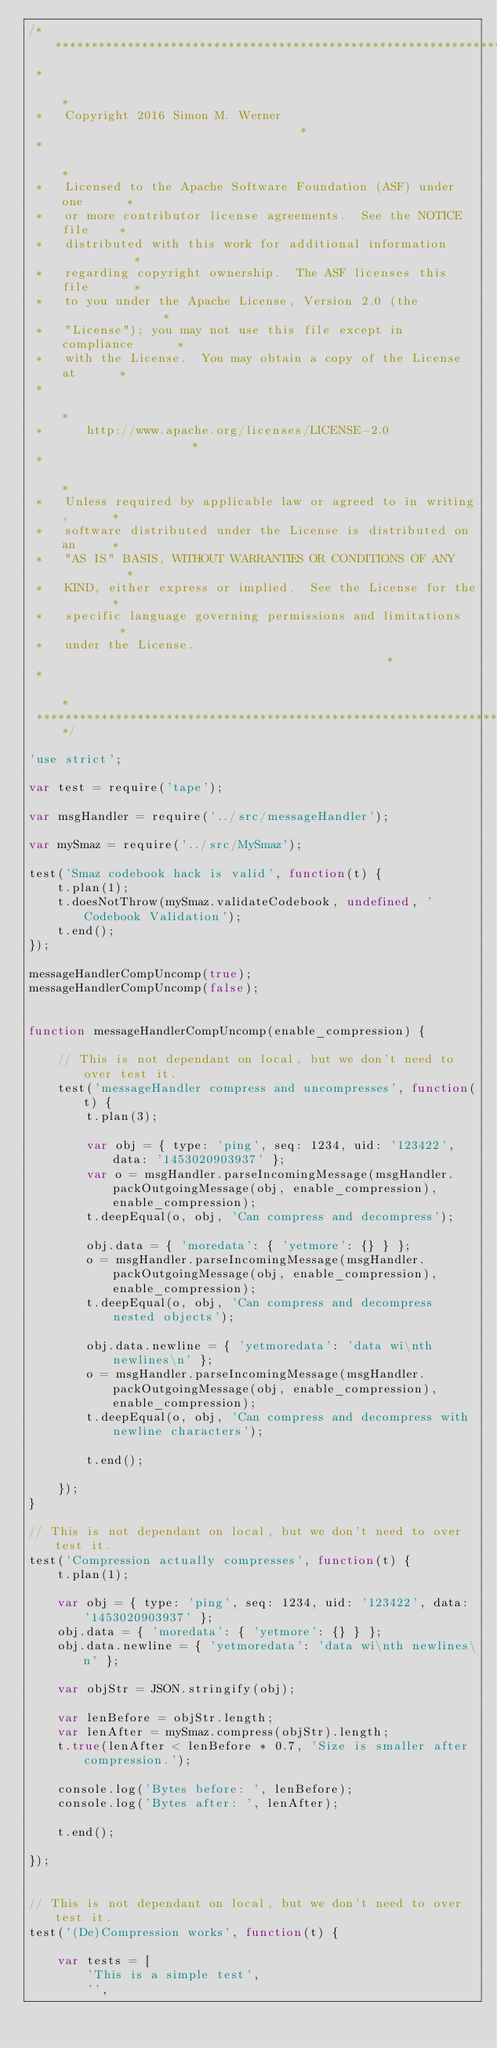Convert code to text. <code><loc_0><loc_0><loc_500><loc_500><_JavaScript_>/*********************************************************************
 *                                                                   *
 *   Copyright 2016 Simon M. Werner                                  *
 *                                                                   *
 *   Licensed to the Apache Software Foundation (ASF) under one      *
 *   or more contributor license agreements.  See the NOTICE file    *
 *   distributed with this work for additional information           *
 *   regarding copyright ownership.  The ASF licenses this file      *
 *   to you under the Apache License, Version 2.0 (the               *
 *   "License"); you may not use this file except in compliance      *
 *   with the License.  You may obtain a copy of the License at      *
 *                                                                   *
 *      http://www.apache.org/licenses/LICENSE-2.0                   *
 *                                                                   *
 *   Unless required by applicable law or agreed to in writing,      *
 *   software distributed under the License is distributed on an     *
 *   "AS IS" BASIS, WITHOUT WARRANTIES OR CONDITIONS OF ANY          *
 *   KIND, either express or implied.  See the License for the       *
 *   specific language governing permissions and limitations         *
 *   under the License.                                              *
 *                                                                   *
 *********************************************************************/

'use strict';

var test = require('tape');

var msgHandler = require('../src/messageHandler');

var mySmaz = require('../src/MySmaz');

test('Smaz codebook hack is valid', function(t) {
    t.plan(1);
    t.doesNotThrow(mySmaz.validateCodebook, undefined, 'Codebook Validation');
    t.end();
});

messageHandlerCompUncomp(true);
messageHandlerCompUncomp(false);


function messageHandlerCompUncomp(enable_compression) {

    // This is not dependant on local, but we don't need to over test it.
    test('messageHandler compress and uncompresses', function(t) {
        t.plan(3);

        var obj = { type: 'ping', seq: 1234, uid: '123422', data: '1453020903937' };
        var o = msgHandler.parseIncomingMessage(msgHandler.packOutgoingMessage(obj, enable_compression), enable_compression);
        t.deepEqual(o, obj, 'Can compress and decompress');

        obj.data = { 'moredata': { 'yetmore': {} } };
        o = msgHandler.parseIncomingMessage(msgHandler.packOutgoingMessage(obj, enable_compression), enable_compression);
        t.deepEqual(o, obj, 'Can compress and decompress nested objects');

        obj.data.newline = { 'yetmoredata': 'data wi\nth newlines\n' };
        o = msgHandler.parseIncomingMessage(msgHandler.packOutgoingMessage(obj, enable_compression), enable_compression);
        t.deepEqual(o, obj, 'Can compress and decompress with newline characters');

        t.end();

    });
}

// This is not dependant on local, but we don't need to over test it.
test('Compression actually compresses', function(t) {
    t.plan(1);

    var obj = { type: 'ping', seq: 1234, uid: '123422', data: '1453020903937' };
    obj.data = { 'moredata': { 'yetmore': {} } };
    obj.data.newline = { 'yetmoredata': 'data wi\nth newlines\n' };

    var objStr = JSON.stringify(obj);

    var lenBefore = objStr.length;
    var lenAfter = mySmaz.compress(objStr).length;
    t.true(lenAfter < lenBefore * 0.7, 'Size is smaller after compression.');

    console.log('Bytes before: ', lenBefore);
    console.log('Bytes after: ', lenAfter);

    t.end();

});


// This is not dependant on local, but we don't need to over test it.
test('(De)Compression works', function(t) {

    var tests = [
        'This is a simple test',
        '',</code> 